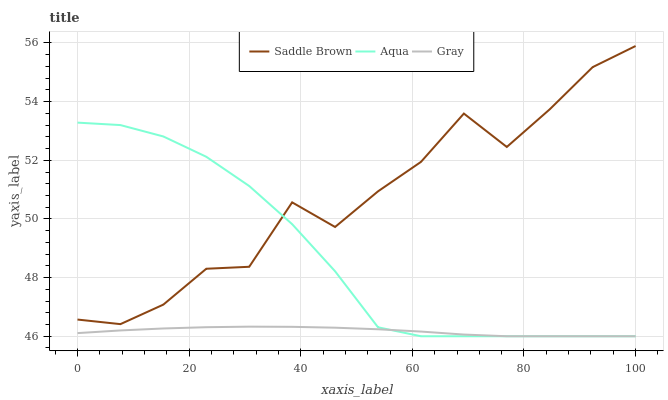Does Gray have the minimum area under the curve?
Answer yes or no. Yes. Does Saddle Brown have the maximum area under the curve?
Answer yes or no. Yes. Does Aqua have the minimum area under the curve?
Answer yes or no. No. Does Aqua have the maximum area under the curve?
Answer yes or no. No. Is Gray the smoothest?
Answer yes or no. Yes. Is Saddle Brown the roughest?
Answer yes or no. Yes. Is Aqua the smoothest?
Answer yes or no. No. Is Aqua the roughest?
Answer yes or no. No. Does Gray have the lowest value?
Answer yes or no. Yes. Does Saddle Brown have the lowest value?
Answer yes or no. No. Does Saddle Brown have the highest value?
Answer yes or no. Yes. Does Aqua have the highest value?
Answer yes or no. No. Is Gray less than Saddle Brown?
Answer yes or no. Yes. Is Saddle Brown greater than Gray?
Answer yes or no. Yes. Does Aqua intersect Gray?
Answer yes or no. Yes. Is Aqua less than Gray?
Answer yes or no. No. Is Aqua greater than Gray?
Answer yes or no. No. Does Gray intersect Saddle Brown?
Answer yes or no. No. 